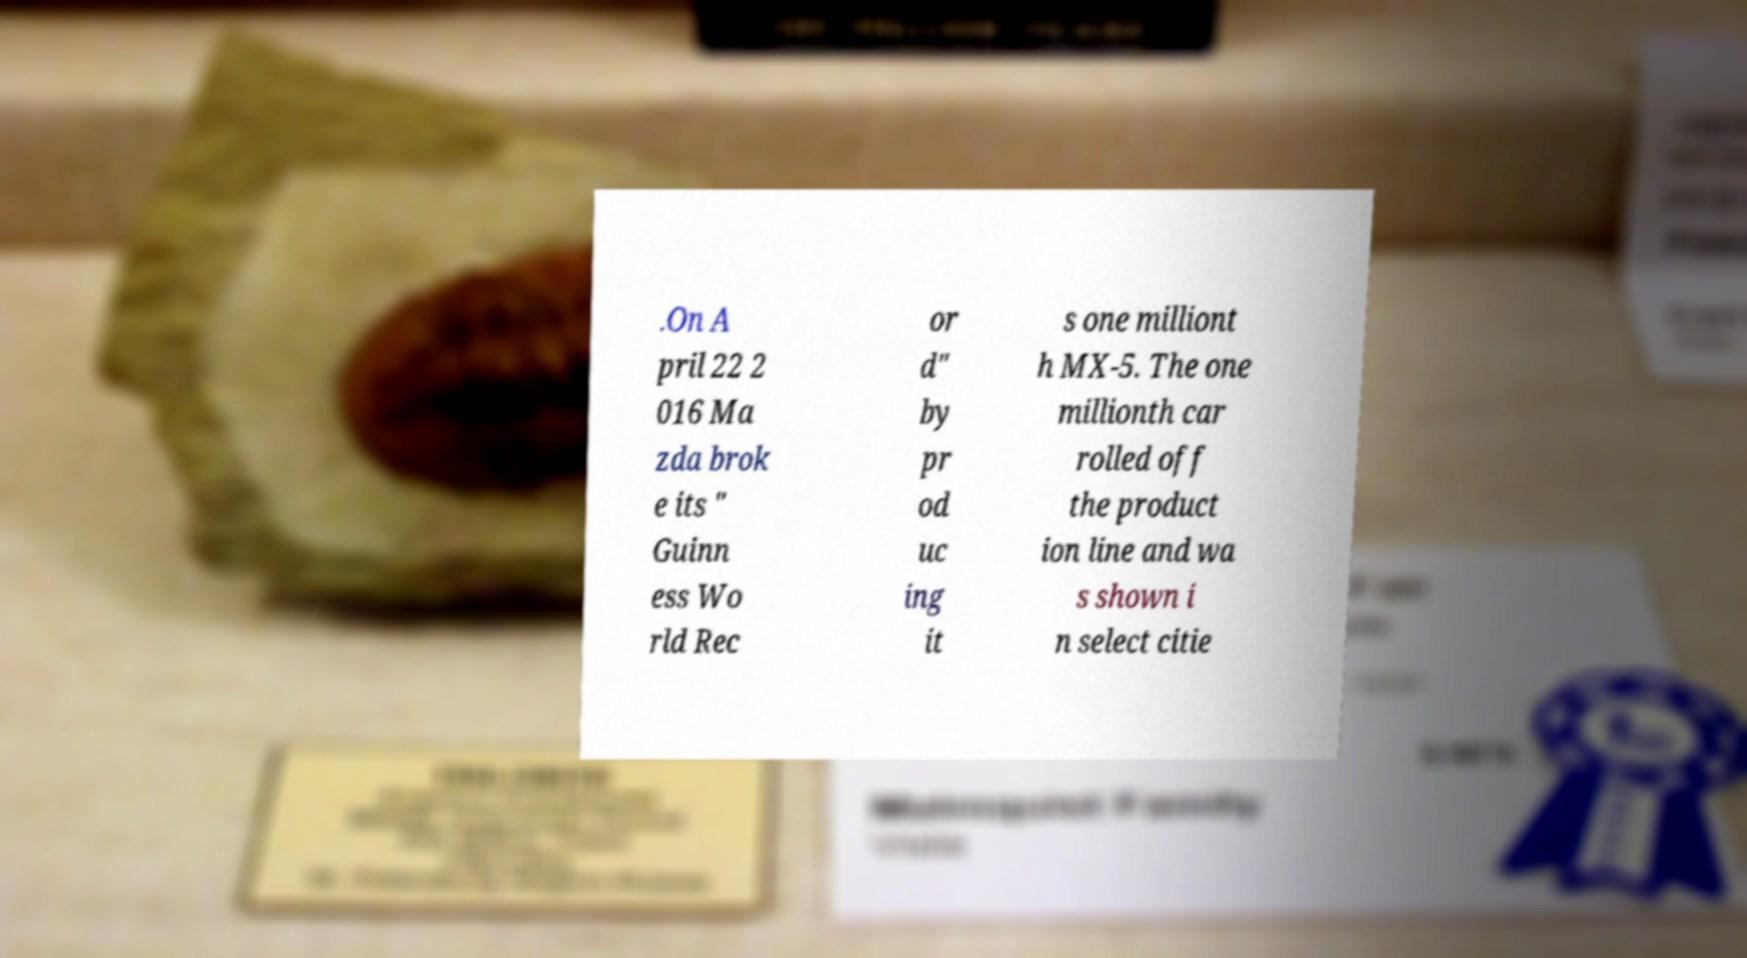Can you read and provide the text displayed in the image?This photo seems to have some interesting text. Can you extract and type it out for me? .On A pril 22 2 016 Ma zda brok e its " Guinn ess Wo rld Rec or d" by pr od uc ing it s one milliont h MX-5. The one millionth car rolled off the product ion line and wa s shown i n select citie 